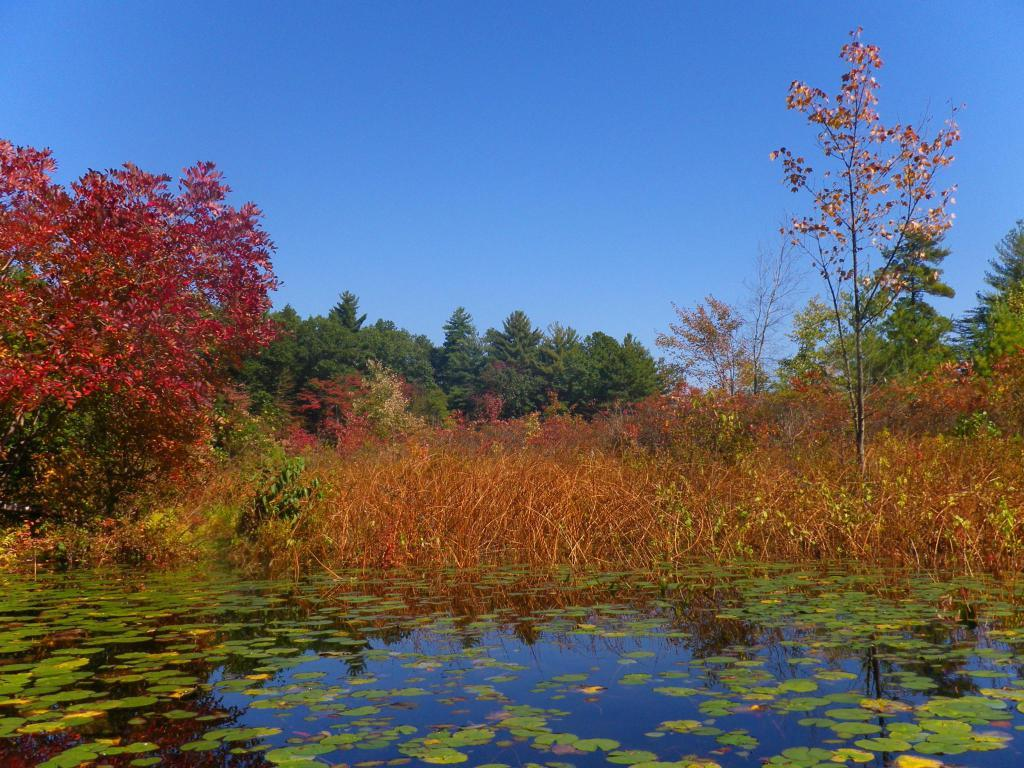What is visible in the image? Water, trees, and the sky are visible in the image. Can you describe the water in the image? The water is visible, but its specific characteristics are not mentioned in the facts. What type of vegetation is present in the image? Trees are present in the image. What is visible in the background of the image? The sky is visible in the background of the image. How many fish can be seen swimming in the water in the image? There is no mention of fish in the image, so it is not possible to determine how many fish might be present. What type of powder is sprinkled on the trees in the image? There is no mention of powder in the image, so it is not possible to determine if any powder is present. 